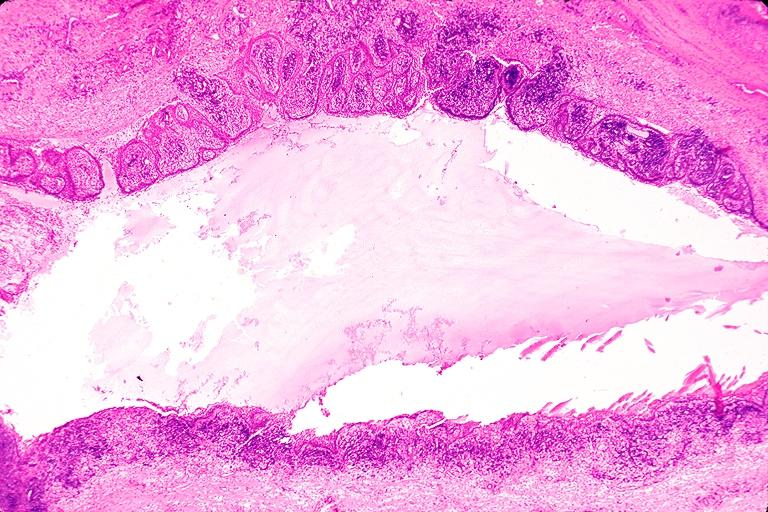does this image show radicular cyst?
Answer the question using a single word or phrase. Yes 